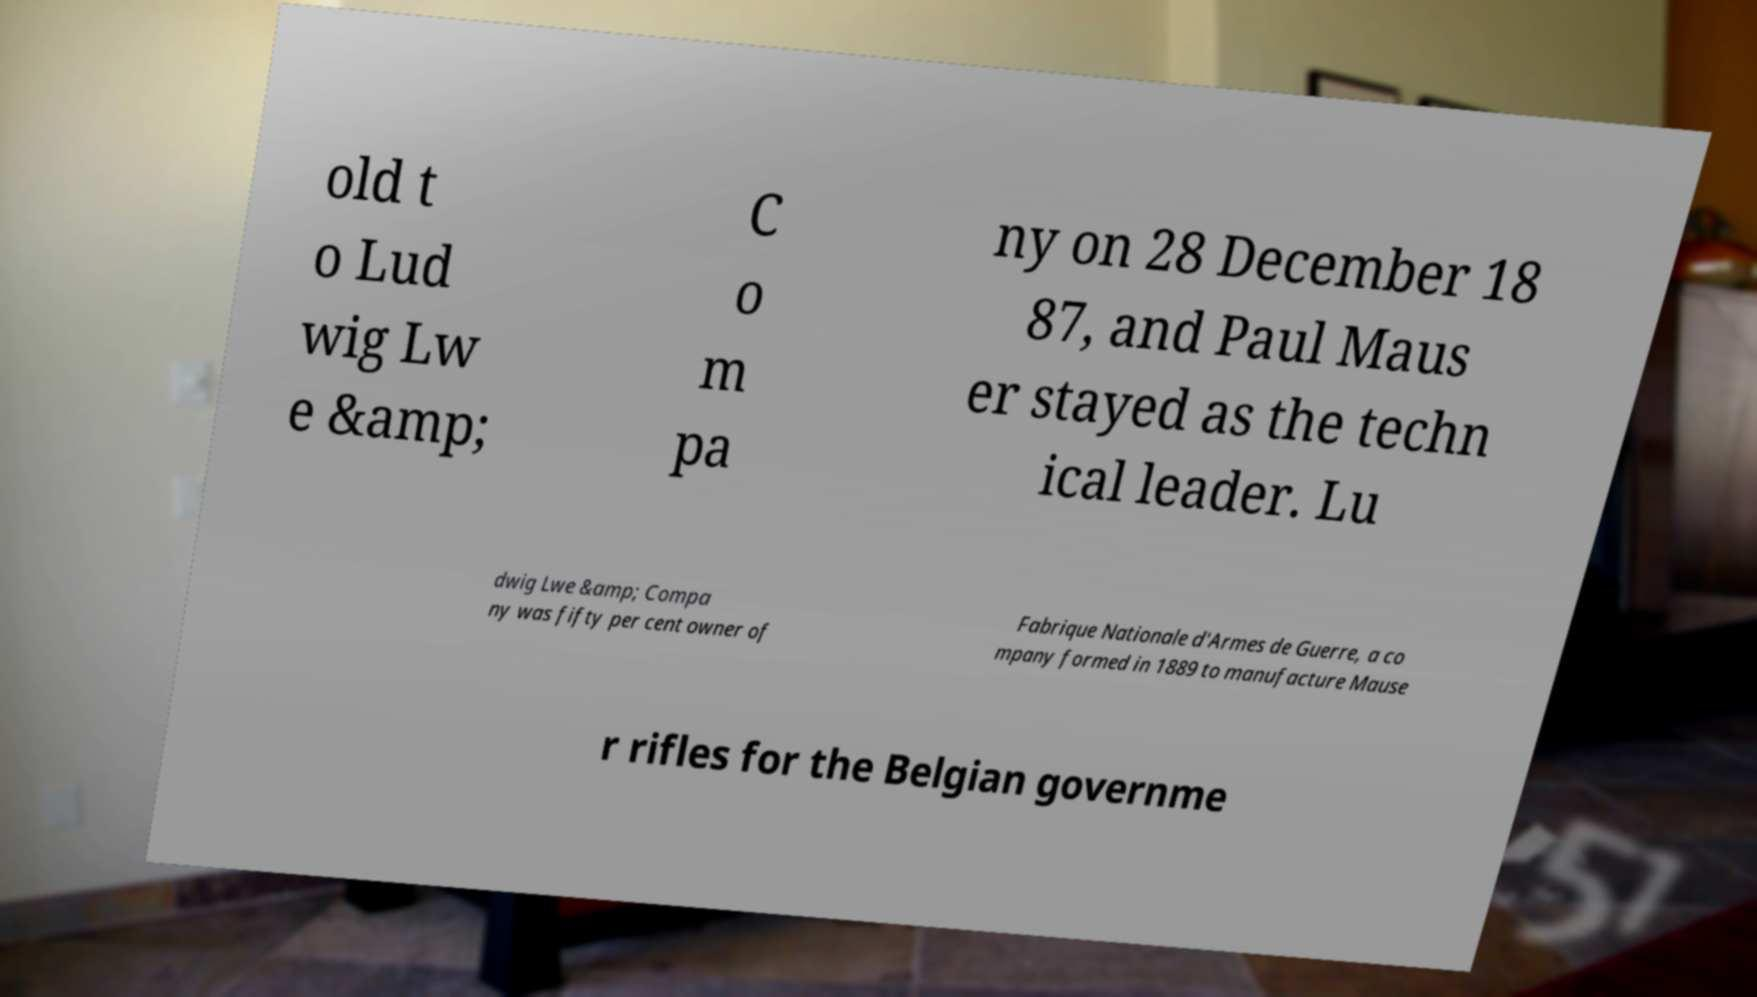Please read and relay the text visible in this image. What does it say? old t o Lud wig Lw e &amp; C o m pa ny on 28 December 18 87, and Paul Maus er stayed as the techn ical leader. Lu dwig Lwe &amp; Compa ny was fifty per cent owner of Fabrique Nationale d'Armes de Guerre, a co mpany formed in 1889 to manufacture Mause r rifles for the Belgian governme 